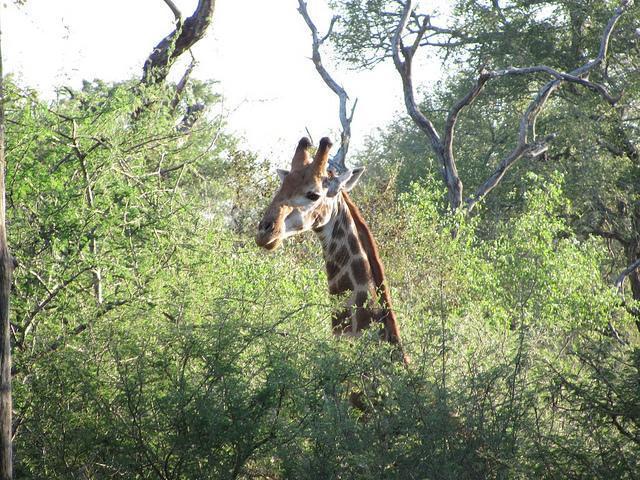How many giraffes are in this picture?
Give a very brief answer. 1. How many cars are there?
Give a very brief answer. 0. 